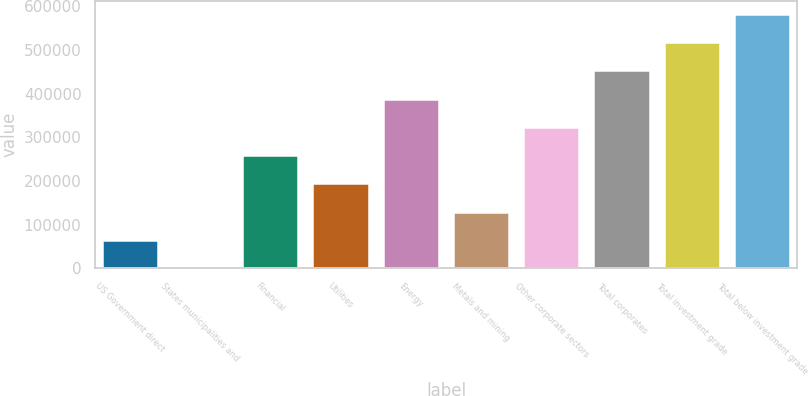Convert chart to OTSL. <chart><loc_0><loc_0><loc_500><loc_500><bar_chart><fcel>US Government direct<fcel>States municipalities and<fcel>Financial<fcel>Utilities<fcel>Energy<fcel>Metals and mining<fcel>Other corporate sectors<fcel>Total corporates<fcel>Total investment grade<fcel>Total below investment grade<nl><fcel>65367.5<fcel>683<fcel>259421<fcel>194736<fcel>388790<fcel>130052<fcel>324106<fcel>453474<fcel>518159<fcel>582844<nl></chart> 